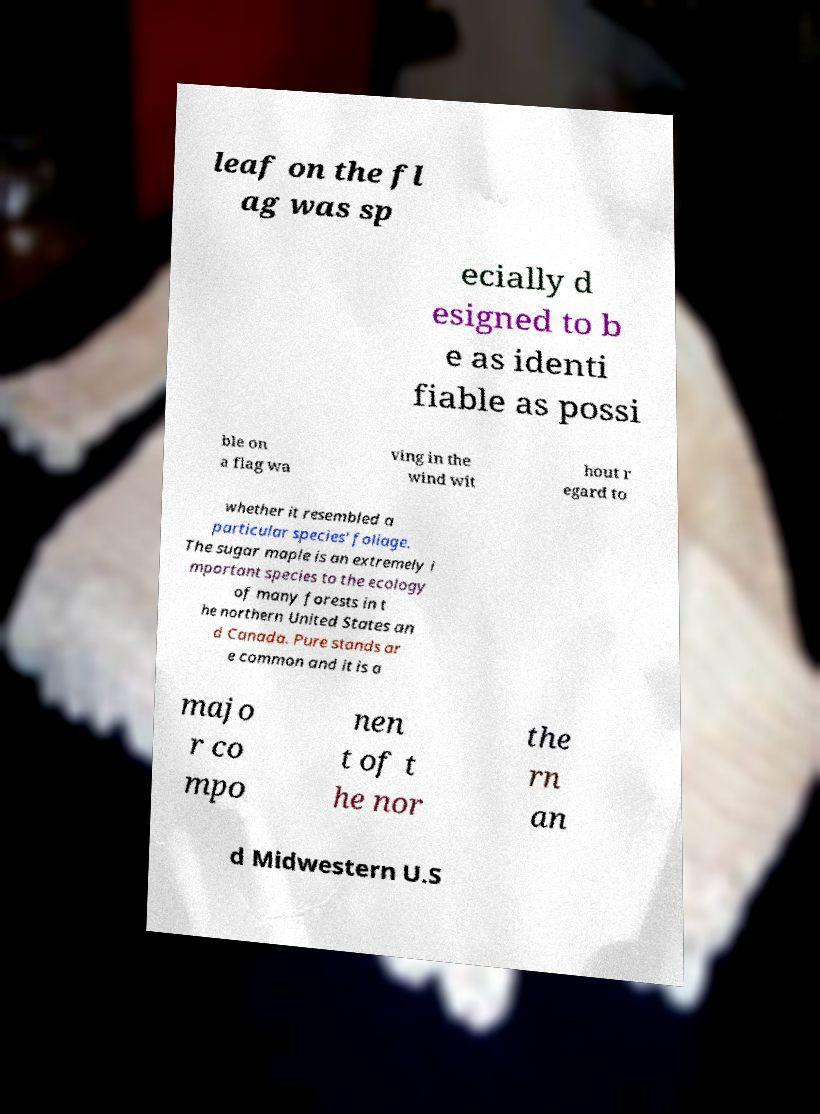There's text embedded in this image that I need extracted. Can you transcribe it verbatim? leaf on the fl ag was sp ecially d esigned to b e as identi fiable as possi ble on a flag wa ving in the wind wit hout r egard to whether it resembled a particular species' foliage. The sugar maple is an extremely i mportant species to the ecology of many forests in t he northern United States an d Canada. Pure stands ar e common and it is a majo r co mpo nen t of t he nor the rn an d Midwestern U.S 